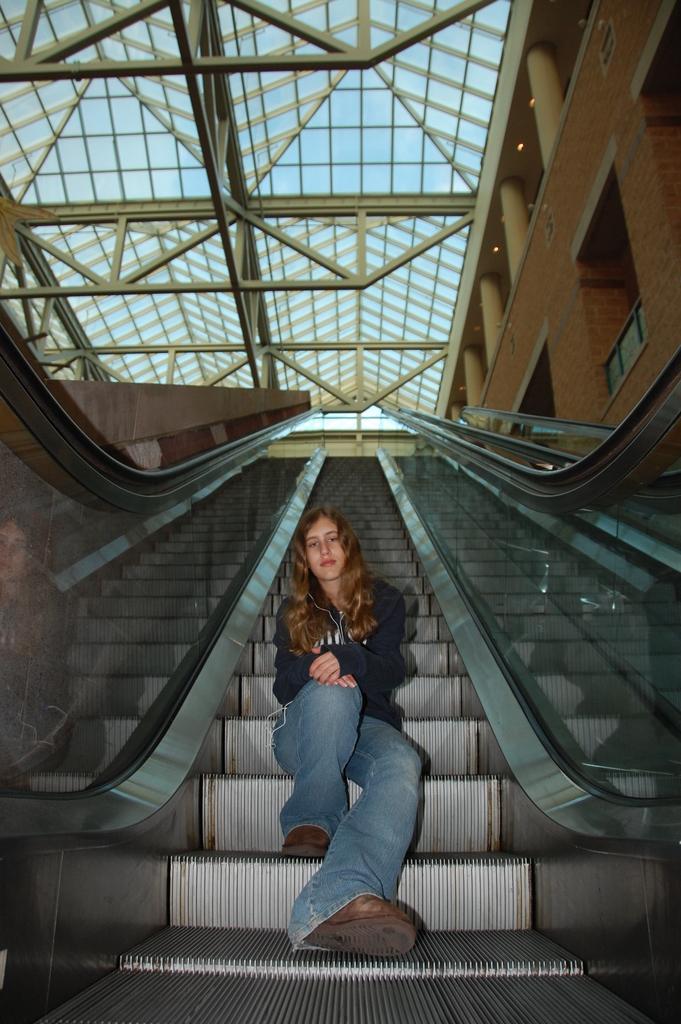In one or two sentences, can you explain what this image depicts? In this picture there is a woman who is wearing jacket, jeans and shoe. She is sitting on the elevator stairs. On the top we can see roof of the building. On the right there is a fencing. Here it's a light. Here it's a sky. 